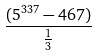Convert formula to latex. <formula><loc_0><loc_0><loc_500><loc_500>\frac { ( 5 ^ { 3 3 7 } - 4 6 7 ) } { \frac { 1 } { 3 } }</formula> 